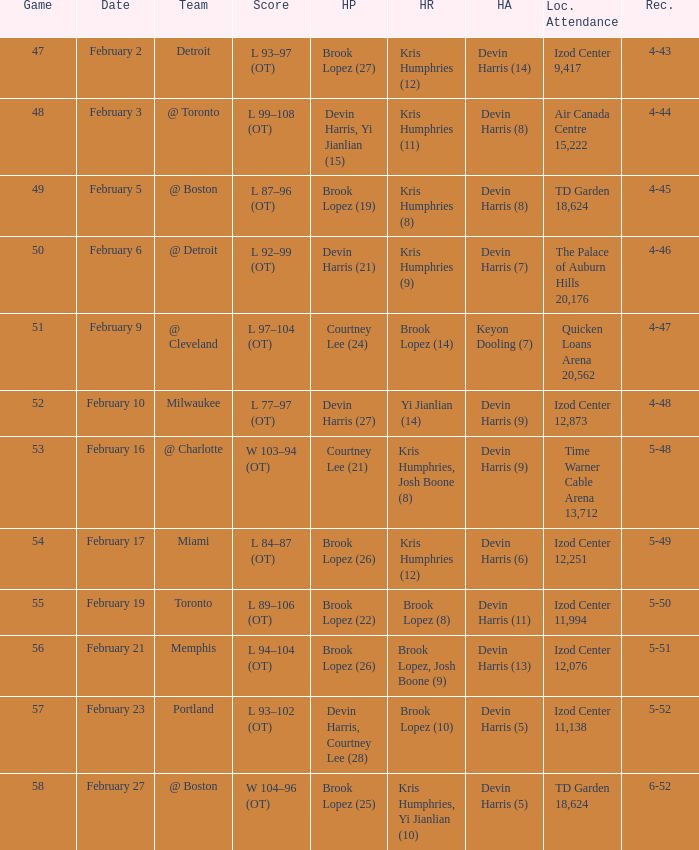What was the record in the game against Memphis? 5-51. 